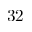Convert formula to latex. <formula><loc_0><loc_0><loc_500><loc_500>3 2</formula> 